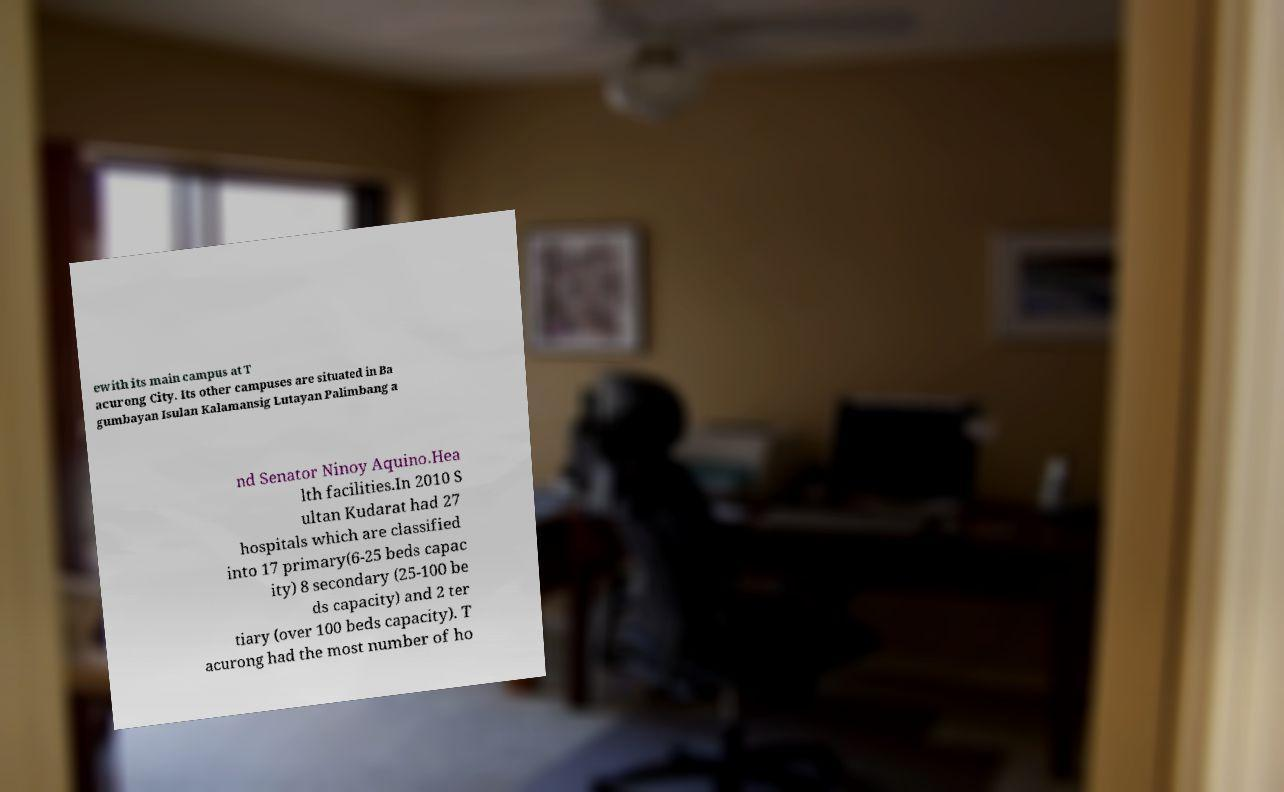Could you extract and type out the text from this image? ewith its main campus at T acurong City. Its other campuses are situated in Ba gumbayan Isulan Kalamansig Lutayan Palimbang a nd Senator Ninoy Aquino.Hea lth facilities.In 2010 S ultan Kudarat had 27 hospitals which are classified into 17 primary(6-25 beds capac ity) 8 secondary (25-100 be ds capacity) and 2 ter tiary (over 100 beds capacity). T acurong had the most number of ho 